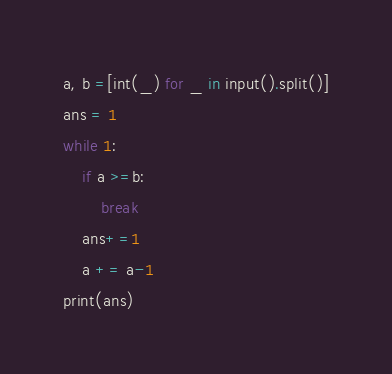<code> <loc_0><loc_0><loc_500><loc_500><_Python_>a, b =[int(_) for _ in input().split()]
ans = 1
while 1:
    if a >=b:
        break
    ans+=1
    a += a-1
print(ans)</code> 